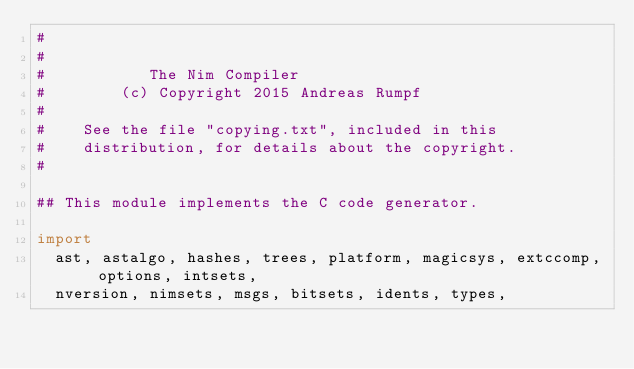Convert code to text. <code><loc_0><loc_0><loc_500><loc_500><_Nim_>#
#
#           The Nim Compiler
#        (c) Copyright 2015 Andreas Rumpf
#
#    See the file "copying.txt", included in this
#    distribution, for details about the copyright.
#

## This module implements the C code generator.

import
  ast, astalgo, hashes, trees, platform, magicsys, extccomp, options, intsets,
  nversion, nimsets, msgs, bitsets, idents, types,</code> 